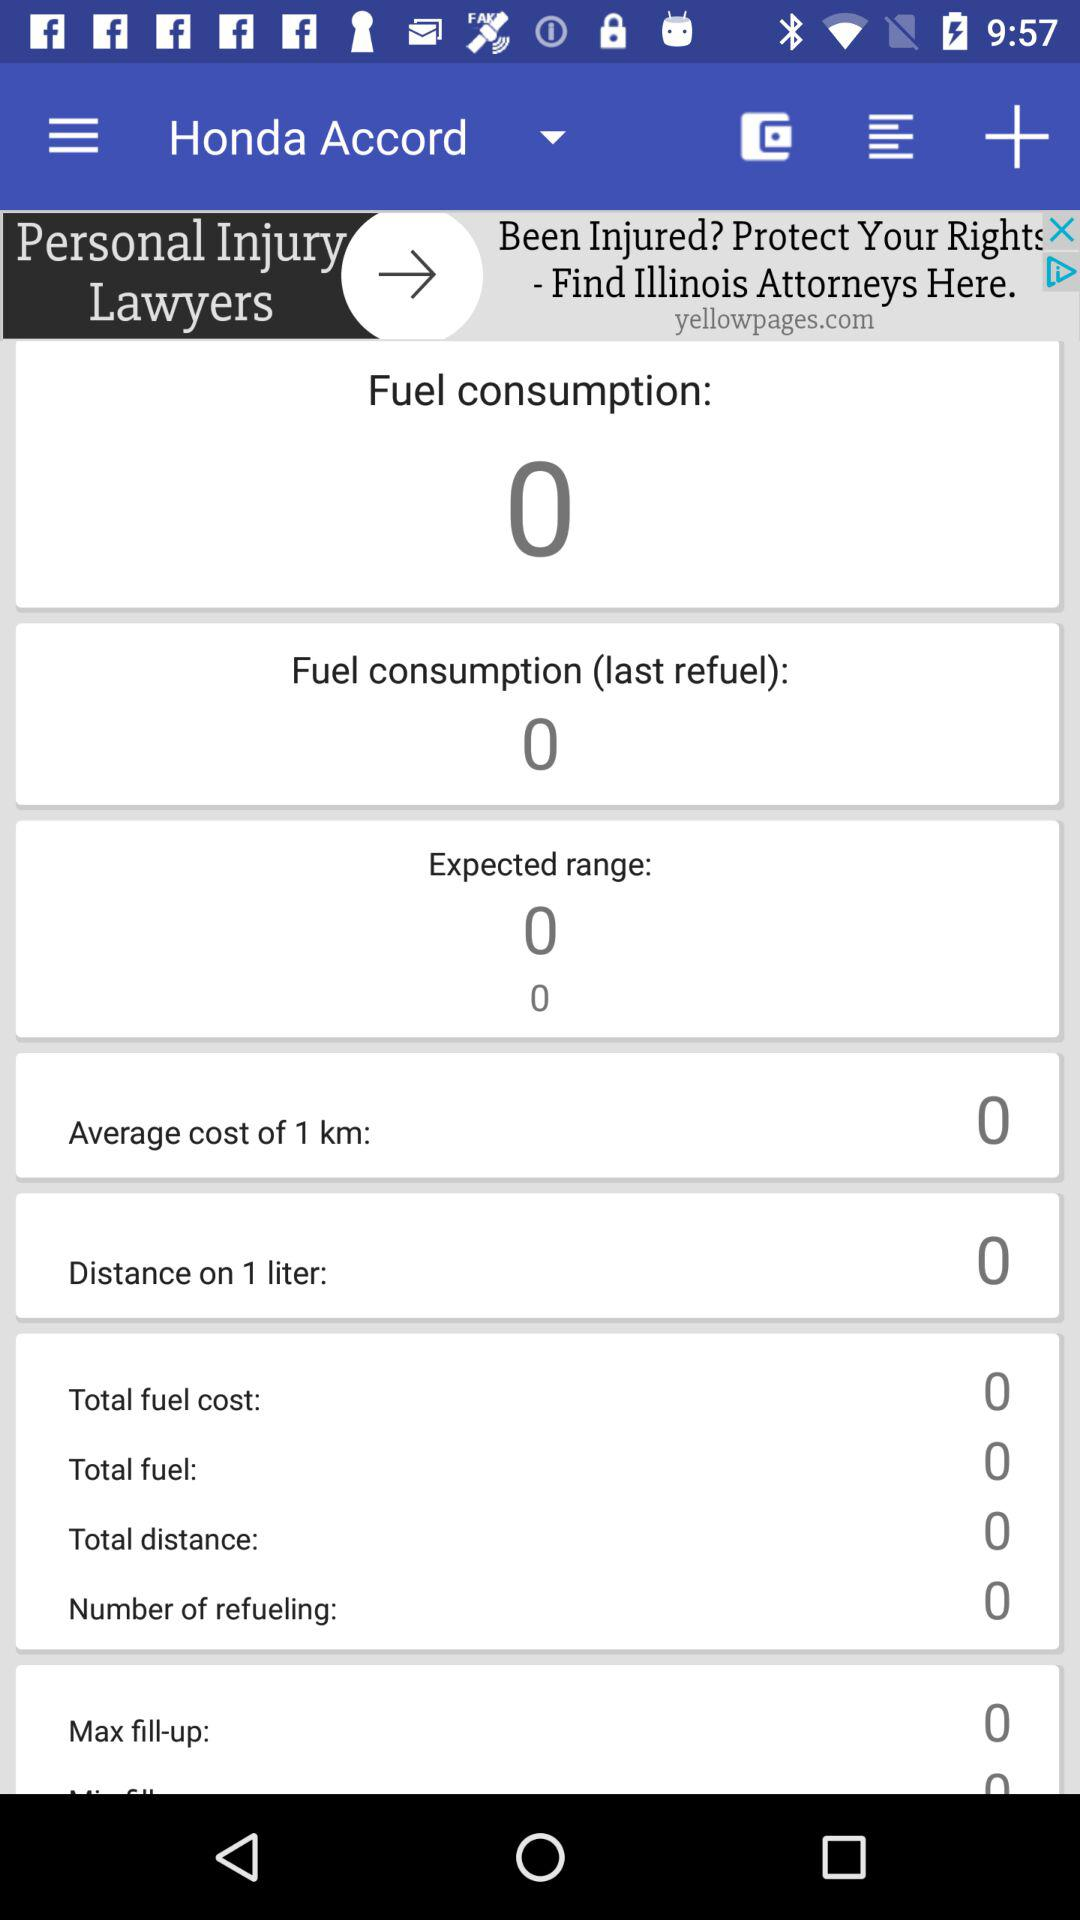What is the expected range? The expected range is 0. 